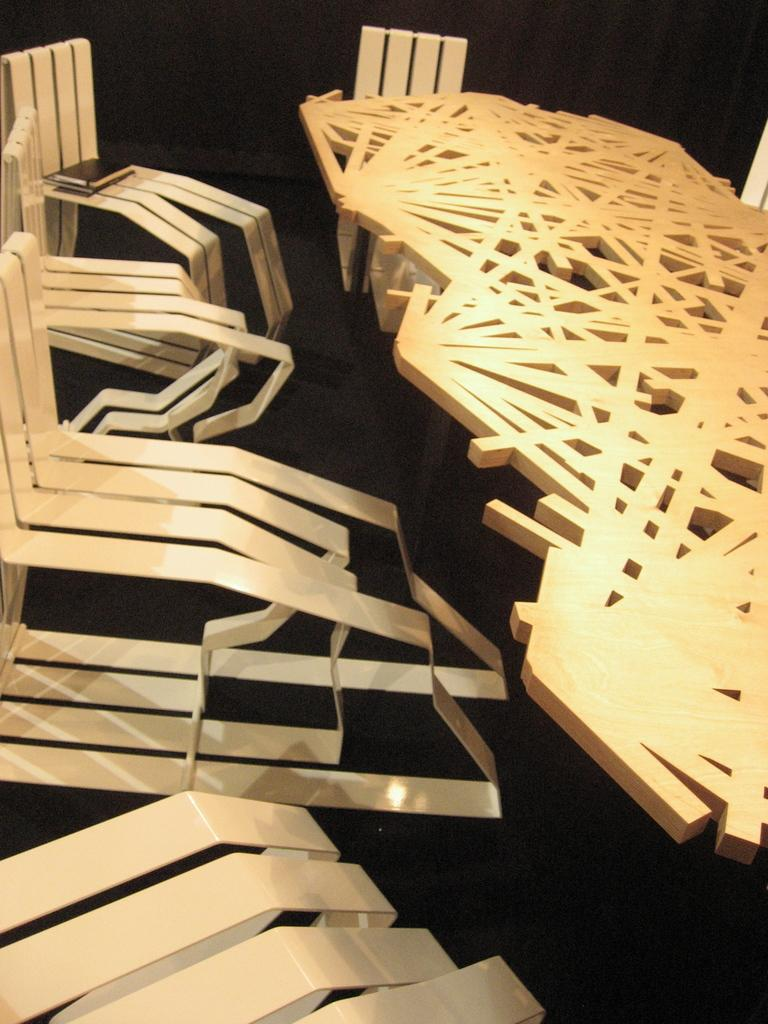What type of furniture is present in the image? There is a table and designed chairs in the image. Can you describe the table in the image? The table is a piece of furniture that is present in the image. How many chairs are visible in the image? There are designed chairs in the image, but the exact number is not specified. How many balls are on the table in the image? There are no balls present on the table in the image. What type of pencil can be seen in the image? There is no pencil present in the image. 